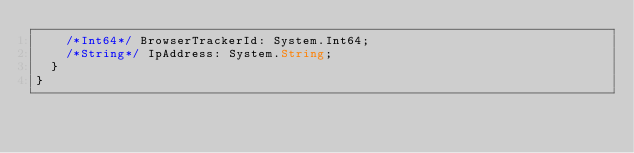Convert code to text. <code><loc_0><loc_0><loc_500><loc_500><_TypeScript_>		/*Int64*/ BrowserTrackerId: System.Int64;
		/*String*/ IpAddress: System.String;
	}
}
</code> 